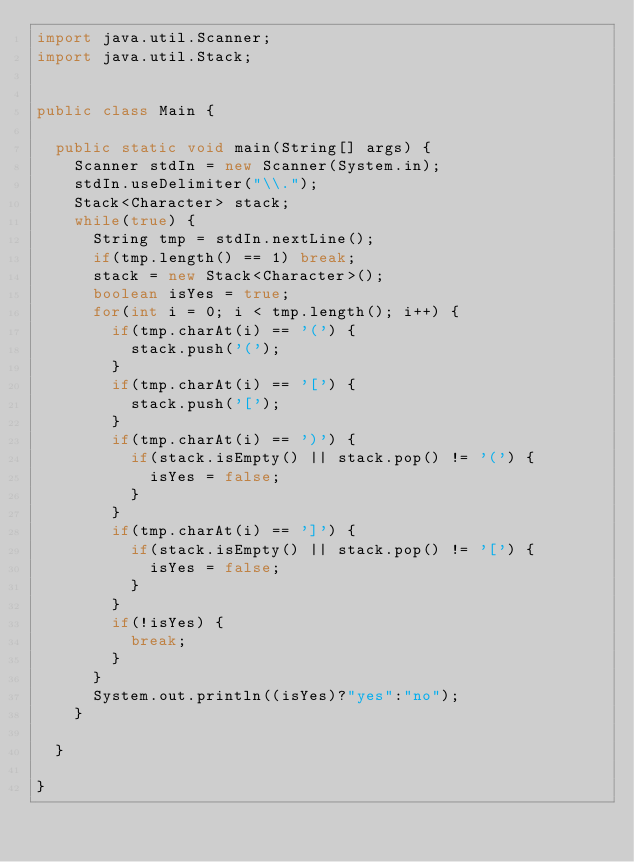Convert code to text. <code><loc_0><loc_0><loc_500><loc_500><_Java_>import java.util.Scanner;
import java.util.Stack;


public class Main {
	
	public static void main(String[] args) {
		Scanner stdIn = new Scanner(System.in);
		stdIn.useDelimiter("\\.");
		Stack<Character> stack;
		while(true) {
			String tmp = stdIn.nextLine();
			if(tmp.length() == 1) break;
			stack = new Stack<Character>();
			boolean isYes = true;
			for(int i = 0; i < tmp.length(); i++) {
				if(tmp.charAt(i) == '(') {
					stack.push('(');
				}
				if(tmp.charAt(i) == '[') {
					stack.push('[');
				}
				if(tmp.charAt(i) == ')') {
					if(stack.isEmpty() || stack.pop() != '(') {
						isYes = false;
					}
				}
				if(tmp.charAt(i) == ']') {
					if(stack.isEmpty() || stack.pop() != '[') {
						isYes = false;
					}
				}
				if(!isYes) {
					break;
				}
			}
			System.out.println((isYes)?"yes":"no");
		}
		
	}
	
}</code> 